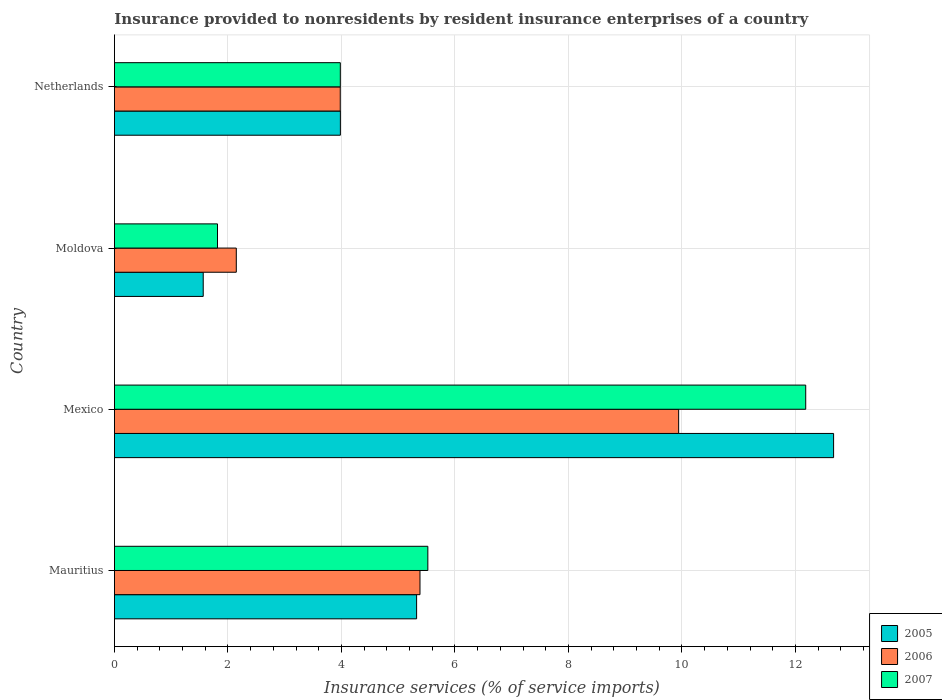How many groups of bars are there?
Your answer should be very brief. 4. Are the number of bars on each tick of the Y-axis equal?
Keep it short and to the point. Yes. How many bars are there on the 2nd tick from the bottom?
Provide a succinct answer. 3. What is the label of the 2nd group of bars from the top?
Your answer should be compact. Moldova. In how many cases, is the number of bars for a given country not equal to the number of legend labels?
Give a very brief answer. 0. What is the insurance provided to nonresidents in 2005 in Mexico?
Make the answer very short. 12.67. Across all countries, what is the maximum insurance provided to nonresidents in 2007?
Your answer should be compact. 12.18. Across all countries, what is the minimum insurance provided to nonresidents in 2007?
Provide a short and direct response. 1.82. In which country was the insurance provided to nonresidents in 2006 maximum?
Offer a very short reply. Mexico. In which country was the insurance provided to nonresidents in 2005 minimum?
Ensure brevity in your answer.  Moldova. What is the total insurance provided to nonresidents in 2007 in the graph?
Provide a succinct answer. 23.5. What is the difference between the insurance provided to nonresidents in 2005 in Moldova and that in Netherlands?
Your response must be concise. -2.42. What is the difference between the insurance provided to nonresidents in 2006 in Mauritius and the insurance provided to nonresidents in 2005 in Mexico?
Make the answer very short. -7.29. What is the average insurance provided to nonresidents in 2007 per country?
Provide a succinct answer. 5.88. What is the difference between the insurance provided to nonresidents in 2007 and insurance provided to nonresidents in 2006 in Mexico?
Ensure brevity in your answer.  2.24. What is the ratio of the insurance provided to nonresidents in 2006 in Mauritius to that in Netherlands?
Give a very brief answer. 1.35. Is the insurance provided to nonresidents in 2007 in Mauritius less than that in Moldova?
Ensure brevity in your answer.  No. What is the difference between the highest and the second highest insurance provided to nonresidents in 2007?
Provide a short and direct response. 6.66. What is the difference between the highest and the lowest insurance provided to nonresidents in 2006?
Keep it short and to the point. 7.79. In how many countries, is the insurance provided to nonresidents in 2007 greater than the average insurance provided to nonresidents in 2007 taken over all countries?
Offer a very short reply. 1. What does the 2nd bar from the top in Netherlands represents?
Ensure brevity in your answer.  2006. What does the 1st bar from the bottom in Mauritius represents?
Make the answer very short. 2005. How many bars are there?
Give a very brief answer. 12. How many countries are there in the graph?
Give a very brief answer. 4. Are the values on the major ticks of X-axis written in scientific E-notation?
Give a very brief answer. No. Where does the legend appear in the graph?
Your response must be concise. Bottom right. How many legend labels are there?
Your response must be concise. 3. How are the legend labels stacked?
Provide a succinct answer. Vertical. What is the title of the graph?
Offer a terse response. Insurance provided to nonresidents by resident insurance enterprises of a country. What is the label or title of the X-axis?
Provide a succinct answer. Insurance services (% of service imports). What is the label or title of the Y-axis?
Offer a very short reply. Country. What is the Insurance services (% of service imports) of 2005 in Mauritius?
Ensure brevity in your answer.  5.32. What is the Insurance services (% of service imports) of 2006 in Mauritius?
Your response must be concise. 5.38. What is the Insurance services (% of service imports) in 2007 in Mauritius?
Provide a short and direct response. 5.52. What is the Insurance services (% of service imports) of 2005 in Mexico?
Offer a very short reply. 12.67. What is the Insurance services (% of service imports) in 2006 in Mexico?
Give a very brief answer. 9.94. What is the Insurance services (% of service imports) in 2007 in Mexico?
Your answer should be very brief. 12.18. What is the Insurance services (% of service imports) of 2005 in Moldova?
Give a very brief answer. 1.56. What is the Insurance services (% of service imports) in 2006 in Moldova?
Offer a very short reply. 2.15. What is the Insurance services (% of service imports) of 2007 in Moldova?
Provide a succinct answer. 1.82. What is the Insurance services (% of service imports) of 2005 in Netherlands?
Your response must be concise. 3.98. What is the Insurance services (% of service imports) in 2006 in Netherlands?
Keep it short and to the point. 3.98. What is the Insurance services (% of service imports) of 2007 in Netherlands?
Keep it short and to the point. 3.98. Across all countries, what is the maximum Insurance services (% of service imports) of 2005?
Offer a very short reply. 12.67. Across all countries, what is the maximum Insurance services (% of service imports) of 2006?
Provide a succinct answer. 9.94. Across all countries, what is the maximum Insurance services (% of service imports) in 2007?
Your response must be concise. 12.18. Across all countries, what is the minimum Insurance services (% of service imports) of 2005?
Your response must be concise. 1.56. Across all countries, what is the minimum Insurance services (% of service imports) of 2006?
Your answer should be very brief. 2.15. Across all countries, what is the minimum Insurance services (% of service imports) in 2007?
Offer a very short reply. 1.82. What is the total Insurance services (% of service imports) of 2005 in the graph?
Give a very brief answer. 23.54. What is the total Insurance services (% of service imports) of 2006 in the graph?
Your answer should be very brief. 21.45. What is the total Insurance services (% of service imports) in 2007 in the graph?
Offer a very short reply. 23.5. What is the difference between the Insurance services (% of service imports) of 2005 in Mauritius and that in Mexico?
Keep it short and to the point. -7.35. What is the difference between the Insurance services (% of service imports) in 2006 in Mauritius and that in Mexico?
Give a very brief answer. -4.56. What is the difference between the Insurance services (% of service imports) in 2007 in Mauritius and that in Mexico?
Make the answer very short. -6.66. What is the difference between the Insurance services (% of service imports) in 2005 in Mauritius and that in Moldova?
Keep it short and to the point. 3.76. What is the difference between the Insurance services (% of service imports) of 2006 in Mauritius and that in Moldova?
Ensure brevity in your answer.  3.24. What is the difference between the Insurance services (% of service imports) in 2007 in Mauritius and that in Moldova?
Your answer should be compact. 3.71. What is the difference between the Insurance services (% of service imports) of 2005 in Mauritius and that in Netherlands?
Offer a terse response. 1.34. What is the difference between the Insurance services (% of service imports) of 2006 in Mauritius and that in Netherlands?
Make the answer very short. 1.4. What is the difference between the Insurance services (% of service imports) in 2007 in Mauritius and that in Netherlands?
Your answer should be compact. 1.54. What is the difference between the Insurance services (% of service imports) in 2005 in Mexico and that in Moldova?
Your answer should be compact. 11.11. What is the difference between the Insurance services (% of service imports) in 2006 in Mexico and that in Moldova?
Offer a very short reply. 7.79. What is the difference between the Insurance services (% of service imports) in 2007 in Mexico and that in Moldova?
Keep it short and to the point. 10.36. What is the difference between the Insurance services (% of service imports) of 2005 in Mexico and that in Netherlands?
Offer a very short reply. 8.69. What is the difference between the Insurance services (% of service imports) of 2006 in Mexico and that in Netherlands?
Offer a terse response. 5.96. What is the difference between the Insurance services (% of service imports) of 2007 in Mexico and that in Netherlands?
Your answer should be compact. 8.2. What is the difference between the Insurance services (% of service imports) in 2005 in Moldova and that in Netherlands?
Offer a very short reply. -2.42. What is the difference between the Insurance services (% of service imports) of 2006 in Moldova and that in Netherlands?
Give a very brief answer. -1.83. What is the difference between the Insurance services (% of service imports) of 2007 in Moldova and that in Netherlands?
Offer a terse response. -2.16. What is the difference between the Insurance services (% of service imports) of 2005 in Mauritius and the Insurance services (% of service imports) of 2006 in Mexico?
Make the answer very short. -4.62. What is the difference between the Insurance services (% of service imports) of 2005 in Mauritius and the Insurance services (% of service imports) of 2007 in Mexico?
Ensure brevity in your answer.  -6.86. What is the difference between the Insurance services (% of service imports) of 2006 in Mauritius and the Insurance services (% of service imports) of 2007 in Mexico?
Ensure brevity in your answer.  -6.8. What is the difference between the Insurance services (% of service imports) in 2005 in Mauritius and the Insurance services (% of service imports) in 2006 in Moldova?
Offer a very short reply. 3.18. What is the difference between the Insurance services (% of service imports) in 2005 in Mauritius and the Insurance services (% of service imports) in 2007 in Moldova?
Your answer should be very brief. 3.51. What is the difference between the Insurance services (% of service imports) in 2006 in Mauritius and the Insurance services (% of service imports) in 2007 in Moldova?
Keep it short and to the point. 3.57. What is the difference between the Insurance services (% of service imports) of 2005 in Mauritius and the Insurance services (% of service imports) of 2006 in Netherlands?
Provide a short and direct response. 1.35. What is the difference between the Insurance services (% of service imports) of 2005 in Mauritius and the Insurance services (% of service imports) of 2007 in Netherlands?
Provide a short and direct response. 1.34. What is the difference between the Insurance services (% of service imports) of 2006 in Mauritius and the Insurance services (% of service imports) of 2007 in Netherlands?
Provide a succinct answer. 1.4. What is the difference between the Insurance services (% of service imports) of 2005 in Mexico and the Insurance services (% of service imports) of 2006 in Moldova?
Ensure brevity in your answer.  10.53. What is the difference between the Insurance services (% of service imports) in 2005 in Mexico and the Insurance services (% of service imports) in 2007 in Moldova?
Offer a very short reply. 10.86. What is the difference between the Insurance services (% of service imports) of 2006 in Mexico and the Insurance services (% of service imports) of 2007 in Moldova?
Make the answer very short. 8.13. What is the difference between the Insurance services (% of service imports) of 2005 in Mexico and the Insurance services (% of service imports) of 2006 in Netherlands?
Provide a succinct answer. 8.69. What is the difference between the Insurance services (% of service imports) in 2005 in Mexico and the Insurance services (% of service imports) in 2007 in Netherlands?
Provide a short and direct response. 8.69. What is the difference between the Insurance services (% of service imports) in 2006 in Mexico and the Insurance services (% of service imports) in 2007 in Netherlands?
Provide a short and direct response. 5.96. What is the difference between the Insurance services (% of service imports) in 2005 in Moldova and the Insurance services (% of service imports) in 2006 in Netherlands?
Your answer should be compact. -2.41. What is the difference between the Insurance services (% of service imports) of 2005 in Moldova and the Insurance services (% of service imports) of 2007 in Netherlands?
Keep it short and to the point. -2.42. What is the difference between the Insurance services (% of service imports) of 2006 in Moldova and the Insurance services (% of service imports) of 2007 in Netherlands?
Give a very brief answer. -1.83. What is the average Insurance services (% of service imports) of 2005 per country?
Offer a very short reply. 5.89. What is the average Insurance services (% of service imports) in 2006 per country?
Offer a terse response. 5.36. What is the average Insurance services (% of service imports) in 2007 per country?
Offer a terse response. 5.88. What is the difference between the Insurance services (% of service imports) of 2005 and Insurance services (% of service imports) of 2006 in Mauritius?
Offer a very short reply. -0.06. What is the difference between the Insurance services (% of service imports) of 2005 and Insurance services (% of service imports) of 2007 in Mauritius?
Provide a succinct answer. -0.2. What is the difference between the Insurance services (% of service imports) in 2006 and Insurance services (% of service imports) in 2007 in Mauritius?
Give a very brief answer. -0.14. What is the difference between the Insurance services (% of service imports) in 2005 and Insurance services (% of service imports) in 2006 in Mexico?
Ensure brevity in your answer.  2.73. What is the difference between the Insurance services (% of service imports) in 2005 and Insurance services (% of service imports) in 2007 in Mexico?
Offer a very short reply. 0.49. What is the difference between the Insurance services (% of service imports) of 2006 and Insurance services (% of service imports) of 2007 in Mexico?
Your answer should be very brief. -2.24. What is the difference between the Insurance services (% of service imports) in 2005 and Insurance services (% of service imports) in 2006 in Moldova?
Give a very brief answer. -0.58. What is the difference between the Insurance services (% of service imports) of 2005 and Insurance services (% of service imports) of 2007 in Moldova?
Provide a short and direct response. -0.25. What is the difference between the Insurance services (% of service imports) of 2006 and Insurance services (% of service imports) of 2007 in Moldova?
Offer a very short reply. 0.33. What is the difference between the Insurance services (% of service imports) of 2005 and Insurance services (% of service imports) of 2006 in Netherlands?
Provide a short and direct response. 0. What is the difference between the Insurance services (% of service imports) in 2005 and Insurance services (% of service imports) in 2007 in Netherlands?
Your answer should be very brief. 0. What is the difference between the Insurance services (% of service imports) of 2006 and Insurance services (% of service imports) of 2007 in Netherlands?
Offer a terse response. -0. What is the ratio of the Insurance services (% of service imports) in 2005 in Mauritius to that in Mexico?
Your answer should be compact. 0.42. What is the ratio of the Insurance services (% of service imports) in 2006 in Mauritius to that in Mexico?
Make the answer very short. 0.54. What is the ratio of the Insurance services (% of service imports) of 2007 in Mauritius to that in Mexico?
Your response must be concise. 0.45. What is the ratio of the Insurance services (% of service imports) in 2005 in Mauritius to that in Moldova?
Offer a very short reply. 3.4. What is the ratio of the Insurance services (% of service imports) of 2006 in Mauritius to that in Moldova?
Offer a very short reply. 2.51. What is the ratio of the Insurance services (% of service imports) of 2007 in Mauritius to that in Moldova?
Your answer should be compact. 3.04. What is the ratio of the Insurance services (% of service imports) of 2005 in Mauritius to that in Netherlands?
Your answer should be compact. 1.34. What is the ratio of the Insurance services (% of service imports) of 2006 in Mauritius to that in Netherlands?
Keep it short and to the point. 1.35. What is the ratio of the Insurance services (% of service imports) of 2007 in Mauritius to that in Netherlands?
Give a very brief answer. 1.39. What is the ratio of the Insurance services (% of service imports) in 2005 in Mexico to that in Moldova?
Offer a terse response. 8.1. What is the ratio of the Insurance services (% of service imports) in 2006 in Mexico to that in Moldova?
Offer a terse response. 4.63. What is the ratio of the Insurance services (% of service imports) of 2007 in Mexico to that in Moldova?
Your answer should be very brief. 6.71. What is the ratio of the Insurance services (% of service imports) in 2005 in Mexico to that in Netherlands?
Offer a terse response. 3.18. What is the ratio of the Insurance services (% of service imports) in 2006 in Mexico to that in Netherlands?
Offer a very short reply. 2.5. What is the ratio of the Insurance services (% of service imports) in 2007 in Mexico to that in Netherlands?
Keep it short and to the point. 3.06. What is the ratio of the Insurance services (% of service imports) of 2005 in Moldova to that in Netherlands?
Ensure brevity in your answer.  0.39. What is the ratio of the Insurance services (% of service imports) of 2006 in Moldova to that in Netherlands?
Give a very brief answer. 0.54. What is the ratio of the Insurance services (% of service imports) of 2007 in Moldova to that in Netherlands?
Keep it short and to the point. 0.46. What is the difference between the highest and the second highest Insurance services (% of service imports) of 2005?
Provide a short and direct response. 7.35. What is the difference between the highest and the second highest Insurance services (% of service imports) of 2006?
Your response must be concise. 4.56. What is the difference between the highest and the second highest Insurance services (% of service imports) of 2007?
Your answer should be very brief. 6.66. What is the difference between the highest and the lowest Insurance services (% of service imports) in 2005?
Ensure brevity in your answer.  11.11. What is the difference between the highest and the lowest Insurance services (% of service imports) in 2006?
Provide a short and direct response. 7.79. What is the difference between the highest and the lowest Insurance services (% of service imports) of 2007?
Provide a succinct answer. 10.36. 